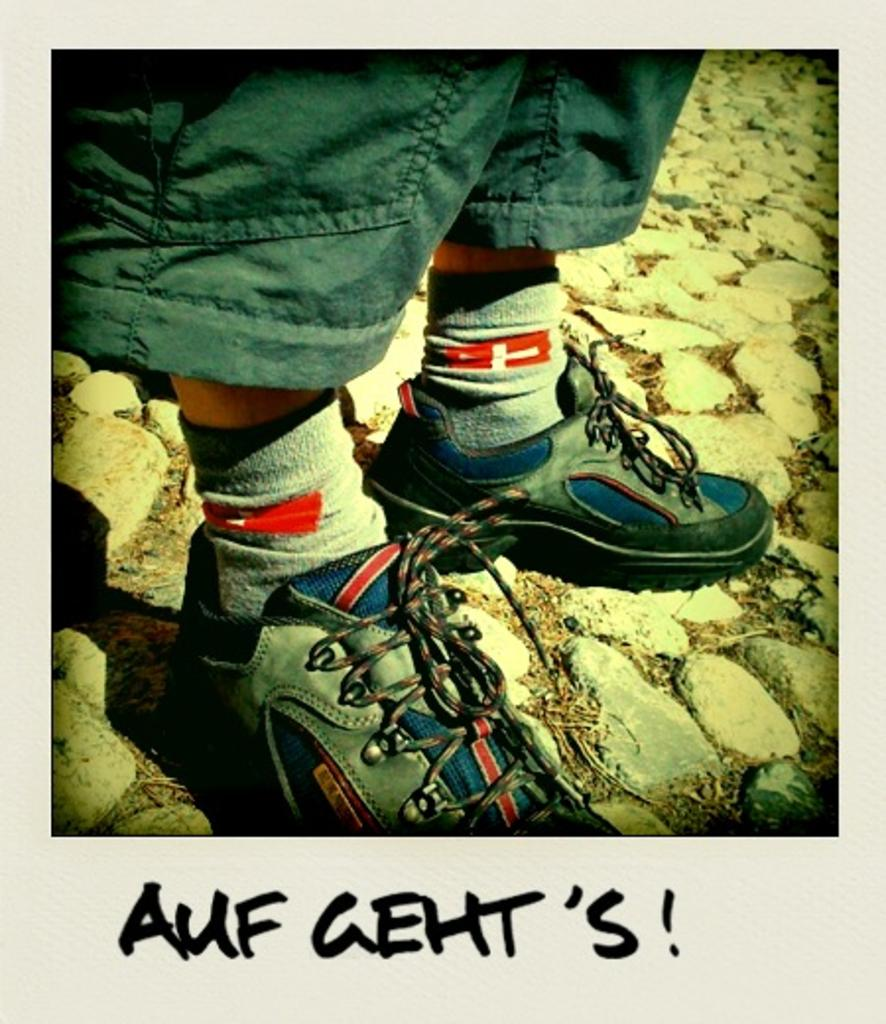What is the main subject of the image? There is a boy standing in the center of the image. What can be seen beneath the boy in the image? There is a floor visible at the bottom of the image. Is there any text present in the image? Yes, there is some text written at the bottom of the image. How does the boy grip the approval in the image? There is no approval present in the image, and therefore no such action can be observed. 